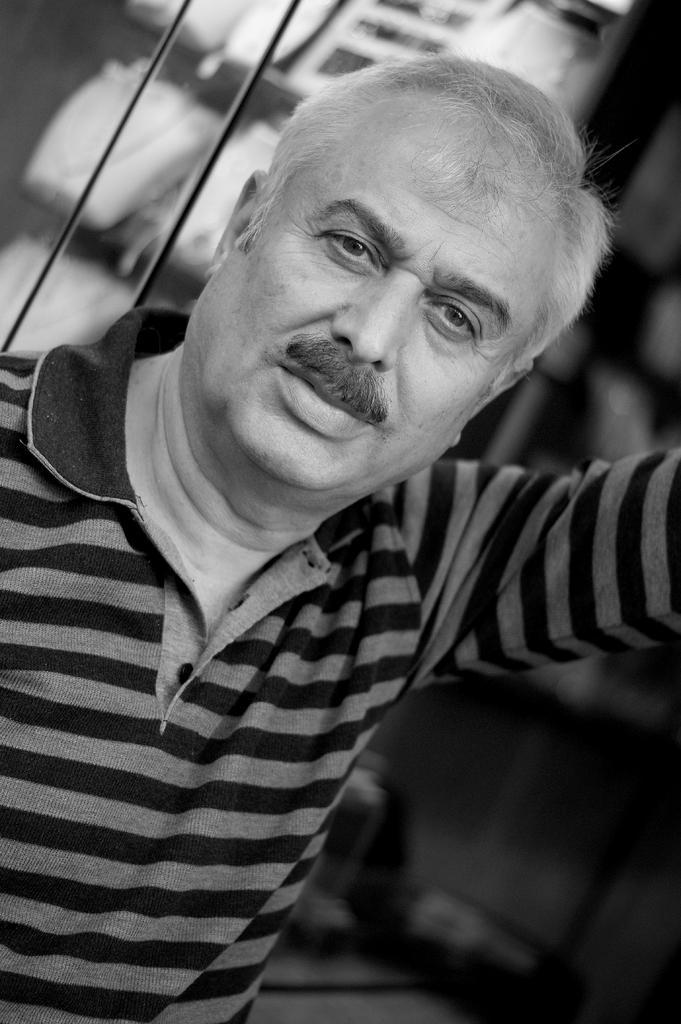How would you summarize this image in a sentence or two? This is black and white image where we can see a man. In the background of the image, we can see the glass and objects. 